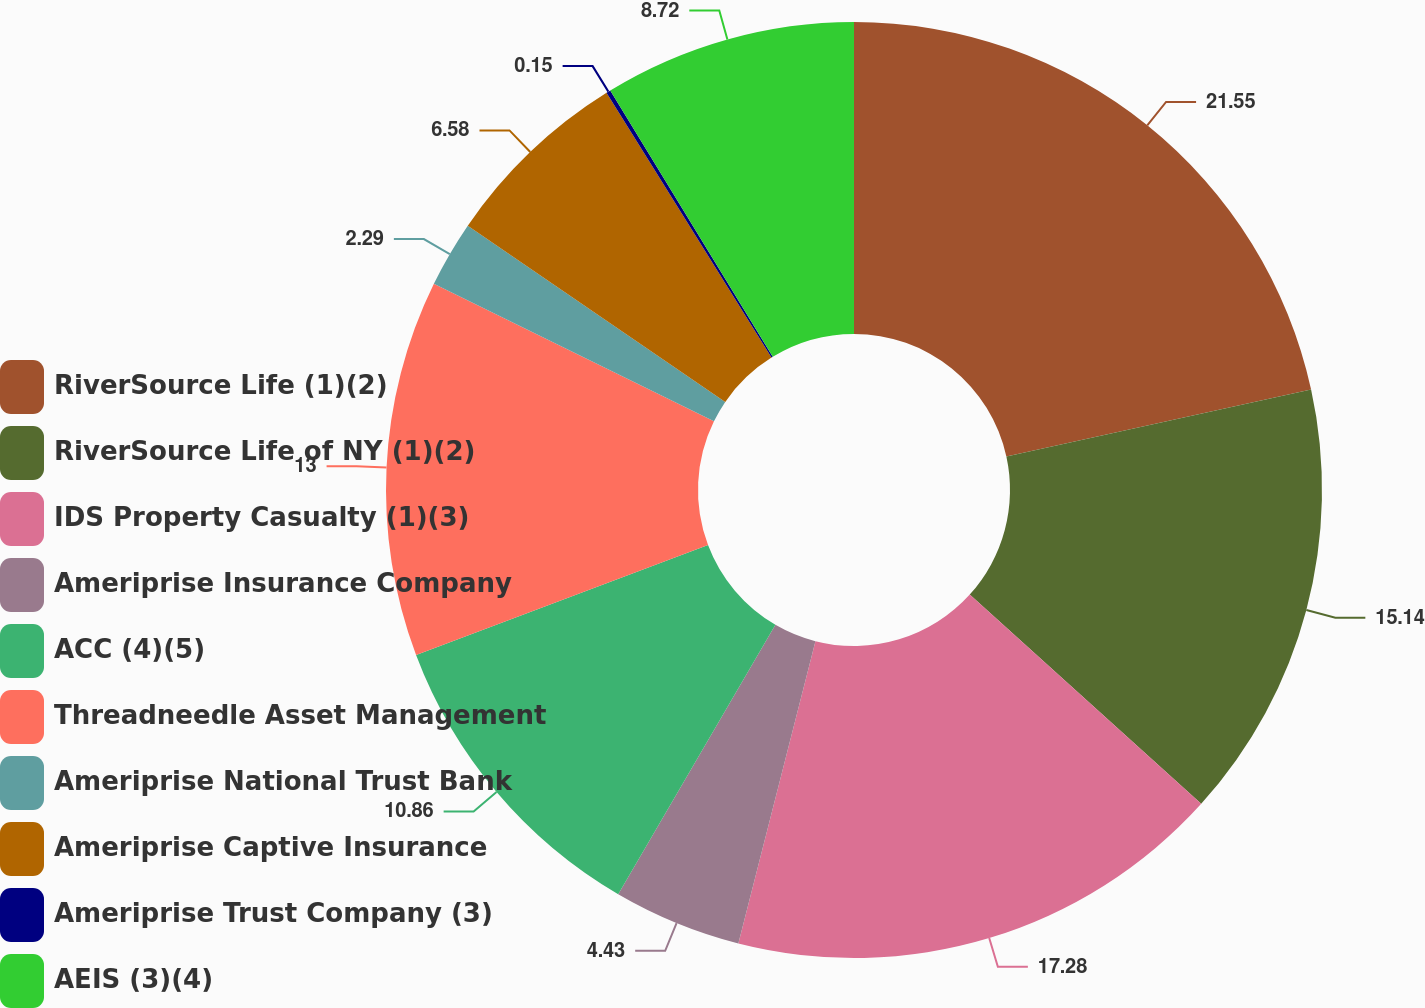Convert chart to OTSL. <chart><loc_0><loc_0><loc_500><loc_500><pie_chart><fcel>RiverSource Life (1)(2)<fcel>RiverSource Life of NY (1)(2)<fcel>IDS Property Casualty (1)(3)<fcel>Ameriprise Insurance Company<fcel>ACC (4)(5)<fcel>Threadneedle Asset Management<fcel>Ameriprise National Trust Bank<fcel>Ameriprise Captive Insurance<fcel>Ameriprise Trust Company (3)<fcel>AEIS (3)(4)<nl><fcel>21.56%<fcel>15.14%<fcel>17.28%<fcel>4.43%<fcel>10.86%<fcel>13.0%<fcel>2.29%<fcel>6.58%<fcel>0.15%<fcel>8.72%<nl></chart> 